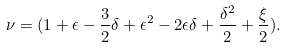Convert formula to latex. <formula><loc_0><loc_0><loc_500><loc_500>\nu = ( 1 + \epsilon - \frac { 3 } { 2 } \delta + \epsilon ^ { 2 } - 2 \epsilon \delta + \frac { \delta ^ { 2 } } { 2 } + \frac { \xi } { 2 } ) .</formula> 